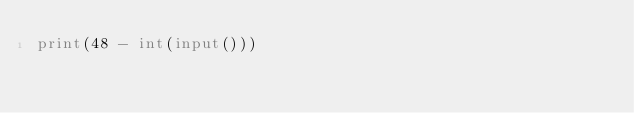<code> <loc_0><loc_0><loc_500><loc_500><_Python_>print(48 - int(input()))
</code> 